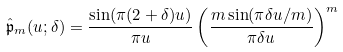<formula> <loc_0><loc_0><loc_500><loc_500>\hat { \mathfrak p } _ { m } ( u ; \delta ) = \frac { \sin ( \pi ( 2 + \delta ) u ) } { \pi u } \left ( \frac { m \sin ( \pi \delta u / m ) } { \pi \delta u } \right ) ^ { m }</formula> 